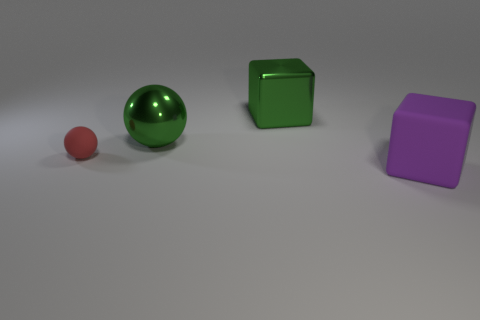Is there anything else that has the same size as the red rubber object?
Provide a succinct answer. No. What is the thing that is right of the red ball and in front of the large shiny sphere made of?
Provide a succinct answer. Rubber. Is the number of big green rubber cylinders less than the number of objects?
Offer a terse response. Yes. Do the tiny rubber thing and the large object that is in front of the red thing have the same shape?
Offer a terse response. No. There is a block on the left side of the purple rubber thing; is it the same size as the small red object?
Offer a very short reply. No. There is a purple rubber thing that is the same size as the green cube; what shape is it?
Keep it short and to the point. Cube. Is the purple rubber thing the same shape as the tiny matte thing?
Offer a very short reply. No. How many other tiny rubber objects are the same shape as the red rubber thing?
Make the answer very short. 0. How many small red rubber balls are in front of the small red object?
Offer a very short reply. 0. Do the large shiny thing behind the big metal ball and the small rubber thing have the same color?
Make the answer very short. No. 